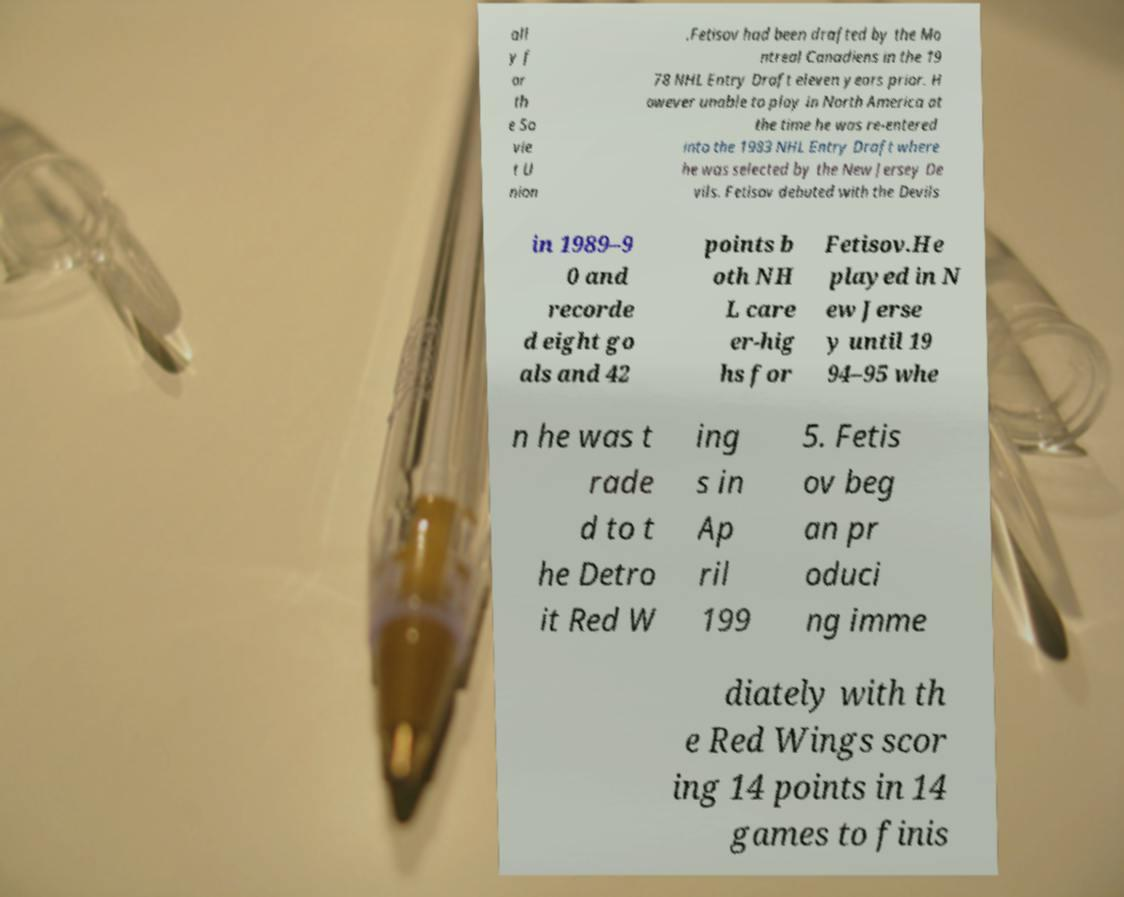Please read and relay the text visible in this image. What does it say? all y f or th e So vie t U nion .Fetisov had been drafted by the Mo ntreal Canadiens in the 19 78 NHL Entry Draft eleven years prior. H owever unable to play in North America at the time he was re-entered into the 1983 NHL Entry Draft where he was selected by the New Jersey De vils. Fetisov debuted with the Devils in 1989–9 0 and recorde d eight go als and 42 points b oth NH L care er-hig hs for Fetisov.He played in N ew Jerse y until 19 94–95 whe n he was t rade d to t he Detro it Red W ing s in Ap ril 199 5. Fetis ov beg an pr oduci ng imme diately with th e Red Wings scor ing 14 points in 14 games to finis 